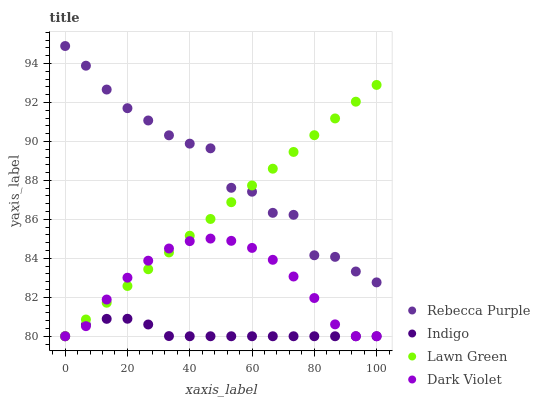Does Indigo have the minimum area under the curve?
Answer yes or no. Yes. Does Rebecca Purple have the maximum area under the curve?
Answer yes or no. Yes. Does Rebecca Purple have the minimum area under the curve?
Answer yes or no. No. Does Indigo have the maximum area under the curve?
Answer yes or no. No. Is Lawn Green the smoothest?
Answer yes or no. Yes. Is Rebecca Purple the roughest?
Answer yes or no. Yes. Is Indigo the smoothest?
Answer yes or no. No. Is Indigo the roughest?
Answer yes or no. No. Does Lawn Green have the lowest value?
Answer yes or no. Yes. Does Rebecca Purple have the lowest value?
Answer yes or no. No. Does Rebecca Purple have the highest value?
Answer yes or no. Yes. Does Indigo have the highest value?
Answer yes or no. No. Is Indigo less than Rebecca Purple?
Answer yes or no. Yes. Is Rebecca Purple greater than Dark Violet?
Answer yes or no. Yes. Does Lawn Green intersect Dark Violet?
Answer yes or no. Yes. Is Lawn Green less than Dark Violet?
Answer yes or no. No. Is Lawn Green greater than Dark Violet?
Answer yes or no. No. Does Indigo intersect Rebecca Purple?
Answer yes or no. No. 